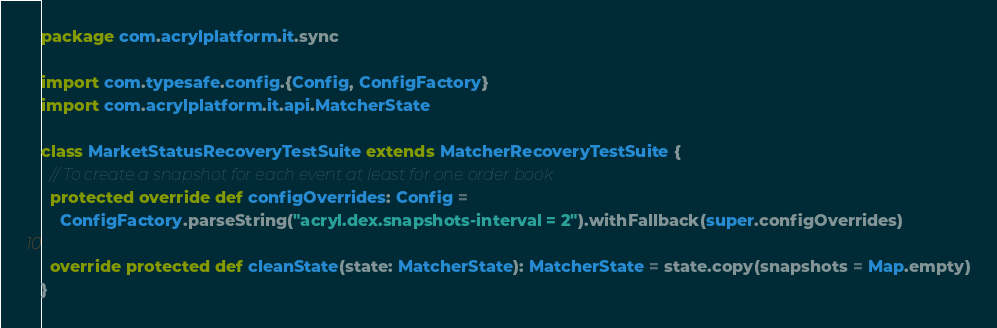<code> <loc_0><loc_0><loc_500><loc_500><_Scala_>package com.acrylplatform.it.sync

import com.typesafe.config.{Config, ConfigFactory}
import com.acrylplatform.it.api.MatcherState

class MarketStatusRecoveryTestSuite extends MatcherRecoveryTestSuite {
  // To create a snapshot for each event at least for one order book
  protected override def configOverrides: Config =
    ConfigFactory.parseString("acryl.dex.snapshots-interval = 2").withFallback(super.configOverrides)

  override protected def cleanState(state: MatcherState): MatcherState = state.copy(snapshots = Map.empty)
}
</code> 